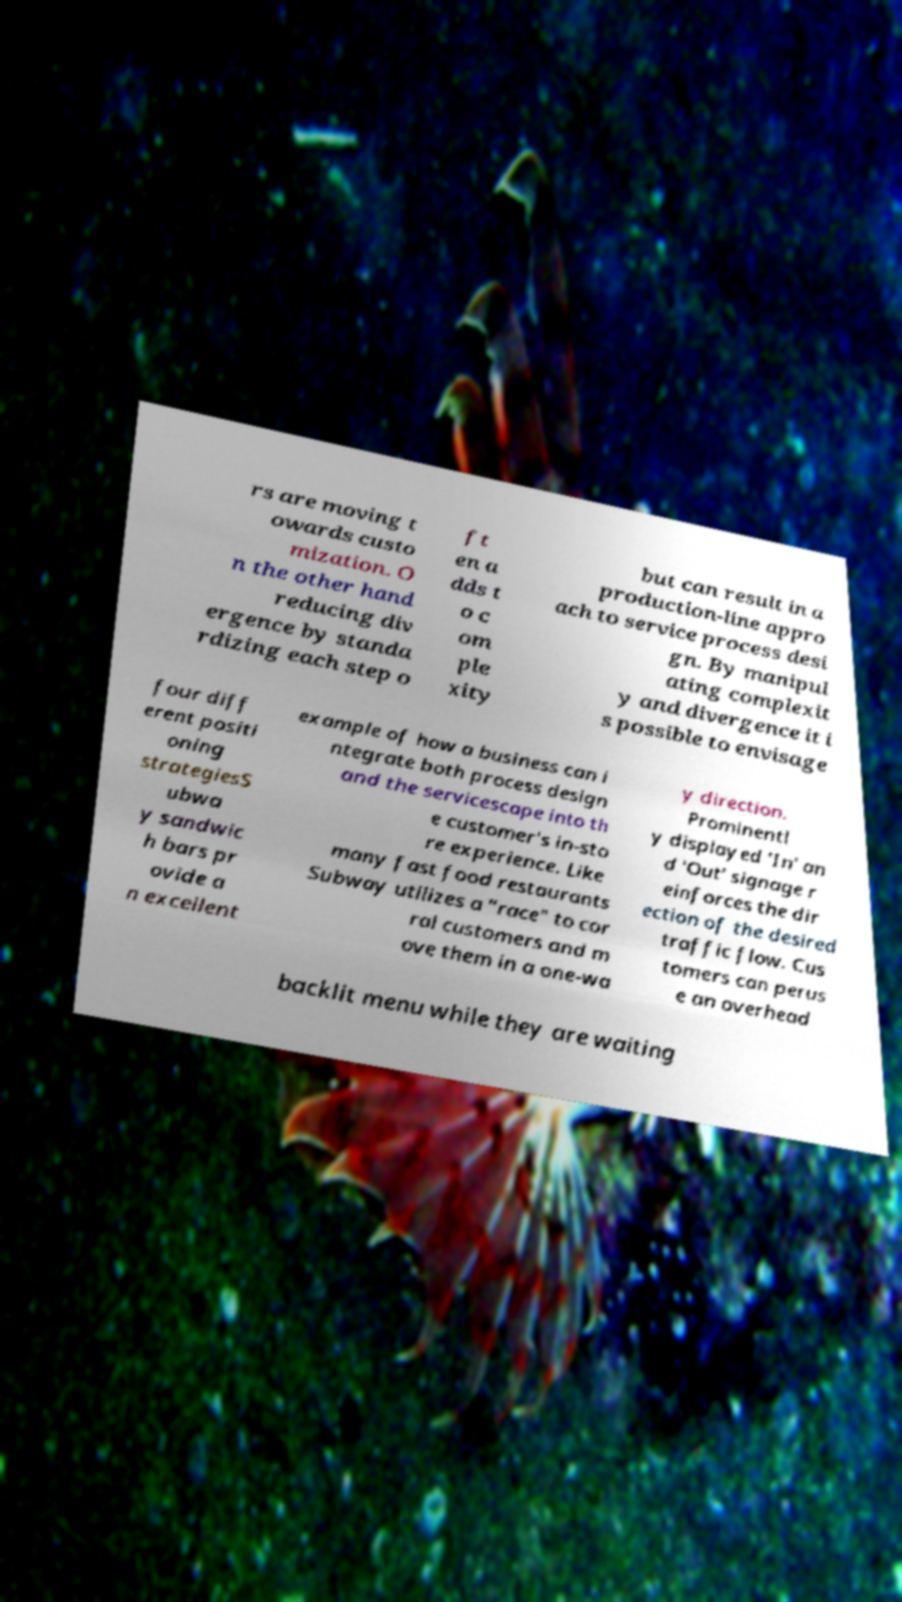I need the written content from this picture converted into text. Can you do that? rs are moving t owards custo mization. O n the other hand reducing div ergence by standa rdizing each step o ft en a dds t o c om ple xity but can result in a production-line appro ach to service process desi gn. By manipul ating complexit y and divergence it i s possible to envisage four diff erent positi oning strategiesS ubwa y sandwic h bars pr ovide a n excellent example of how a business can i ntegrate both process design and the servicescape into th e customer's in-sto re experience. Like many fast food restaurants Subway utilizes a "race" to cor ral customers and m ove them in a one-wa y direction. Prominentl y displayed 'In' an d 'Out' signage r einforces the dir ection of the desired traffic flow. Cus tomers can perus e an overhead backlit menu while they are waiting 